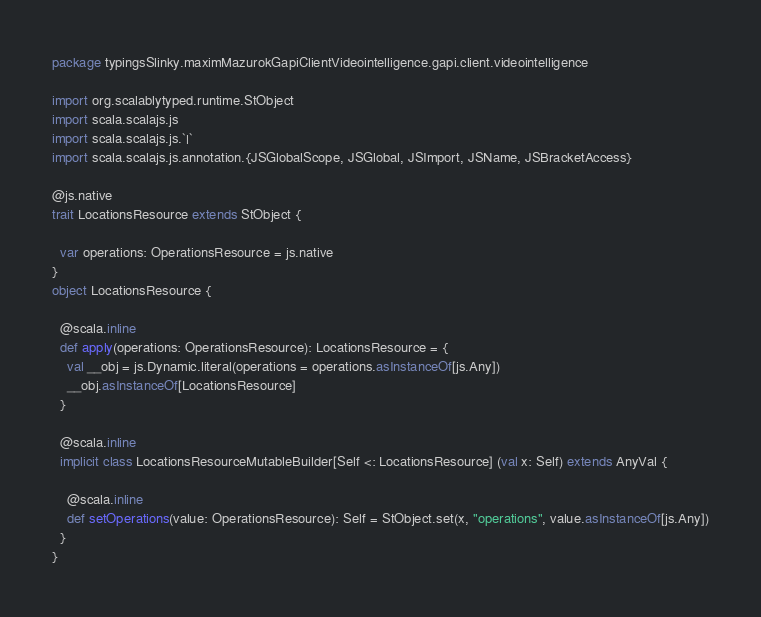Convert code to text. <code><loc_0><loc_0><loc_500><loc_500><_Scala_>package typingsSlinky.maximMazurokGapiClientVideointelligence.gapi.client.videointelligence

import org.scalablytyped.runtime.StObject
import scala.scalajs.js
import scala.scalajs.js.`|`
import scala.scalajs.js.annotation.{JSGlobalScope, JSGlobal, JSImport, JSName, JSBracketAccess}

@js.native
trait LocationsResource extends StObject {
  
  var operations: OperationsResource = js.native
}
object LocationsResource {
  
  @scala.inline
  def apply(operations: OperationsResource): LocationsResource = {
    val __obj = js.Dynamic.literal(operations = operations.asInstanceOf[js.Any])
    __obj.asInstanceOf[LocationsResource]
  }
  
  @scala.inline
  implicit class LocationsResourceMutableBuilder[Self <: LocationsResource] (val x: Self) extends AnyVal {
    
    @scala.inline
    def setOperations(value: OperationsResource): Self = StObject.set(x, "operations", value.asInstanceOf[js.Any])
  }
}
</code> 